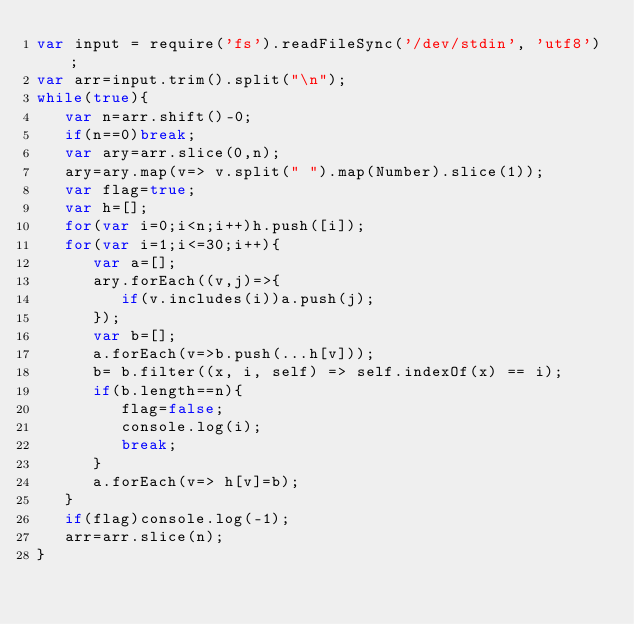<code> <loc_0><loc_0><loc_500><loc_500><_JavaScript_>var input = require('fs').readFileSync('/dev/stdin', 'utf8');
var arr=input.trim().split("\n");
while(true){
   var n=arr.shift()-0;
   if(n==0)break;
   var ary=arr.slice(0,n);
   ary=ary.map(v=> v.split(" ").map(Number).slice(1));
   var flag=true;
   var h=[];
   for(var i=0;i<n;i++)h.push([i]);
   for(var i=1;i<=30;i++){
      var a=[];
      ary.forEach((v,j)=>{
         if(v.includes(i))a.push(j);
      });
      var b=[];
      a.forEach(v=>b.push(...h[v]));
      b= b.filter((x, i, self) => self.indexOf(x) == i);
      if(b.length==n){
         flag=false;
         console.log(i);
         break;
      }
      a.forEach(v=> h[v]=b);
   }
   if(flag)console.log(-1);
   arr=arr.slice(n);
}
</code> 